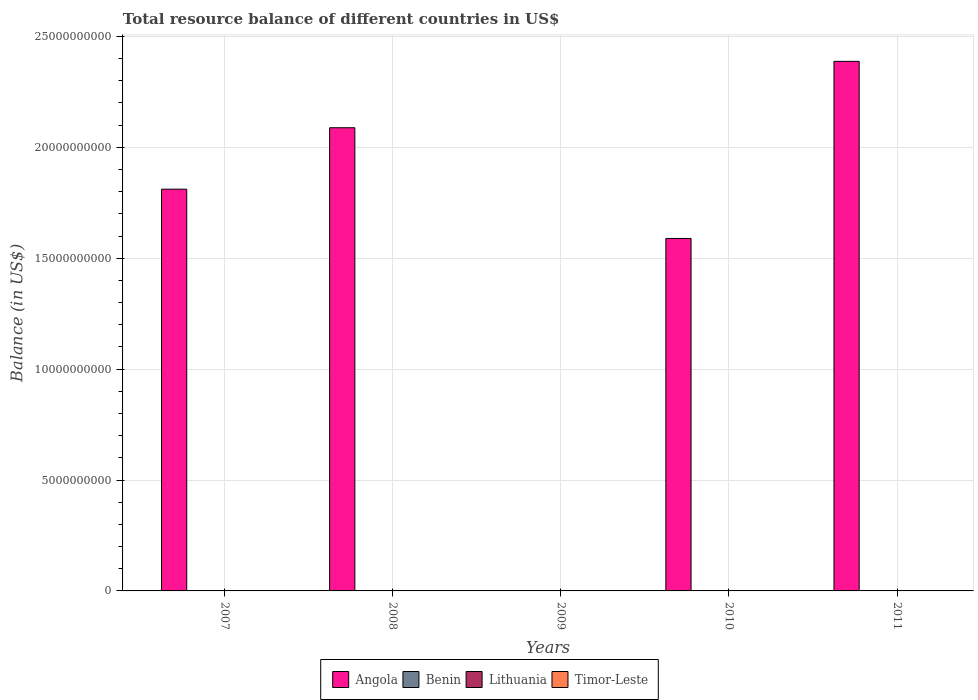How many different coloured bars are there?
Keep it short and to the point. 1. Are the number of bars per tick equal to the number of legend labels?
Ensure brevity in your answer.  No. Are the number of bars on each tick of the X-axis equal?
Your answer should be compact. No. How many bars are there on the 1st tick from the left?
Provide a succinct answer. 1. What is the total resource balance in Benin in 2009?
Your answer should be very brief. 0. Across all years, what is the maximum total resource balance in Angola?
Offer a very short reply. 2.39e+1. Across all years, what is the minimum total resource balance in Angola?
Your answer should be compact. 0. In which year was the total resource balance in Angola maximum?
Your answer should be very brief. 2011. What is the total total resource balance in Angola in the graph?
Your answer should be very brief. 7.88e+1. What is the difference between the total resource balance in Angola in 2008 and that in 2011?
Your response must be concise. -2.99e+09. What is the difference between the total resource balance in Angola in 2011 and the total resource balance in Lithuania in 2008?
Keep it short and to the point. 2.39e+1. What is the average total resource balance in Angola per year?
Keep it short and to the point. 1.58e+1. Is the total resource balance in Angola in 2010 less than that in 2011?
Keep it short and to the point. Yes. What is the difference between the highest and the lowest total resource balance in Angola?
Ensure brevity in your answer.  2.39e+1. In how many years, is the total resource balance in Benin greater than the average total resource balance in Benin taken over all years?
Your answer should be very brief. 0. Is it the case that in every year, the sum of the total resource balance in Benin and total resource balance in Timor-Leste is greater than the sum of total resource balance in Angola and total resource balance in Lithuania?
Your answer should be compact. No. Are all the bars in the graph horizontal?
Offer a very short reply. No. What is the difference between two consecutive major ticks on the Y-axis?
Your response must be concise. 5.00e+09. Are the values on the major ticks of Y-axis written in scientific E-notation?
Your response must be concise. No. Does the graph contain any zero values?
Ensure brevity in your answer.  Yes. Does the graph contain grids?
Make the answer very short. Yes. What is the title of the graph?
Give a very brief answer. Total resource balance of different countries in US$. Does "San Marino" appear as one of the legend labels in the graph?
Offer a terse response. No. What is the label or title of the X-axis?
Your answer should be very brief. Years. What is the label or title of the Y-axis?
Offer a very short reply. Balance (in US$). What is the Balance (in US$) in Angola in 2007?
Keep it short and to the point. 1.81e+1. What is the Balance (in US$) of Benin in 2007?
Give a very brief answer. 0. What is the Balance (in US$) in Angola in 2008?
Offer a very short reply. 2.09e+1. What is the Balance (in US$) in Benin in 2008?
Keep it short and to the point. 0. What is the Balance (in US$) in Lithuania in 2009?
Make the answer very short. 0. What is the Balance (in US$) in Angola in 2010?
Ensure brevity in your answer.  1.59e+1. What is the Balance (in US$) in Lithuania in 2010?
Give a very brief answer. 0. What is the Balance (in US$) in Timor-Leste in 2010?
Your response must be concise. 0. What is the Balance (in US$) of Angola in 2011?
Provide a short and direct response. 2.39e+1. What is the Balance (in US$) of Benin in 2011?
Offer a terse response. 0. Across all years, what is the maximum Balance (in US$) of Angola?
Offer a terse response. 2.39e+1. Across all years, what is the minimum Balance (in US$) in Angola?
Your answer should be very brief. 0. What is the total Balance (in US$) in Angola in the graph?
Provide a succinct answer. 7.88e+1. What is the total Balance (in US$) in Benin in the graph?
Your response must be concise. 0. What is the total Balance (in US$) in Timor-Leste in the graph?
Your answer should be very brief. 0. What is the difference between the Balance (in US$) of Angola in 2007 and that in 2008?
Ensure brevity in your answer.  -2.77e+09. What is the difference between the Balance (in US$) in Angola in 2007 and that in 2010?
Offer a very short reply. 2.22e+09. What is the difference between the Balance (in US$) in Angola in 2007 and that in 2011?
Provide a short and direct response. -5.76e+09. What is the difference between the Balance (in US$) in Angola in 2008 and that in 2010?
Your answer should be very brief. 4.99e+09. What is the difference between the Balance (in US$) of Angola in 2008 and that in 2011?
Provide a succinct answer. -2.99e+09. What is the difference between the Balance (in US$) in Angola in 2010 and that in 2011?
Ensure brevity in your answer.  -7.98e+09. What is the average Balance (in US$) of Angola per year?
Give a very brief answer. 1.58e+1. What is the average Balance (in US$) in Timor-Leste per year?
Ensure brevity in your answer.  0. What is the ratio of the Balance (in US$) in Angola in 2007 to that in 2008?
Provide a short and direct response. 0.87. What is the ratio of the Balance (in US$) in Angola in 2007 to that in 2010?
Ensure brevity in your answer.  1.14. What is the ratio of the Balance (in US$) in Angola in 2007 to that in 2011?
Your answer should be very brief. 0.76. What is the ratio of the Balance (in US$) in Angola in 2008 to that in 2010?
Offer a very short reply. 1.31. What is the ratio of the Balance (in US$) of Angola in 2008 to that in 2011?
Offer a terse response. 0.87. What is the ratio of the Balance (in US$) in Angola in 2010 to that in 2011?
Make the answer very short. 0.67. What is the difference between the highest and the second highest Balance (in US$) in Angola?
Your answer should be compact. 2.99e+09. What is the difference between the highest and the lowest Balance (in US$) in Angola?
Your answer should be very brief. 2.39e+1. 